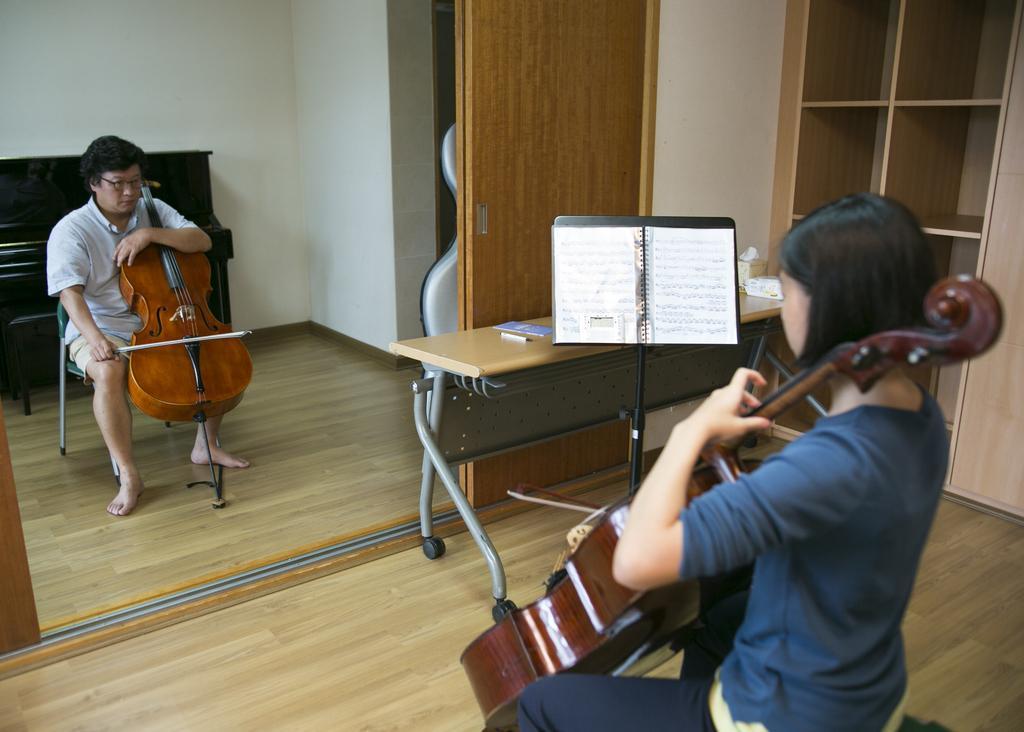How would you summarize this image in a sentence or two? In this image I can see two persons sitting on the chair and playing musical instruments, in front I can see a book on the table, I can see a door in brown color. Background I can see wall in white color. 